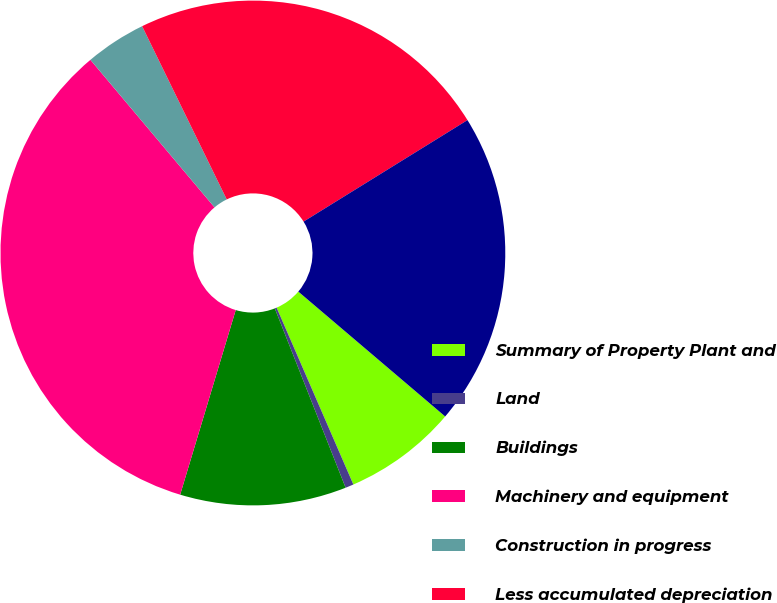<chart> <loc_0><loc_0><loc_500><loc_500><pie_chart><fcel>Summary of Property Plant and<fcel>Land<fcel>Buildings<fcel>Machinery and equipment<fcel>Construction in progress<fcel>Less accumulated depreciation<fcel>Total<nl><fcel>7.27%<fcel>0.53%<fcel>10.64%<fcel>34.22%<fcel>3.9%<fcel>23.41%<fcel>20.04%<nl></chart> 